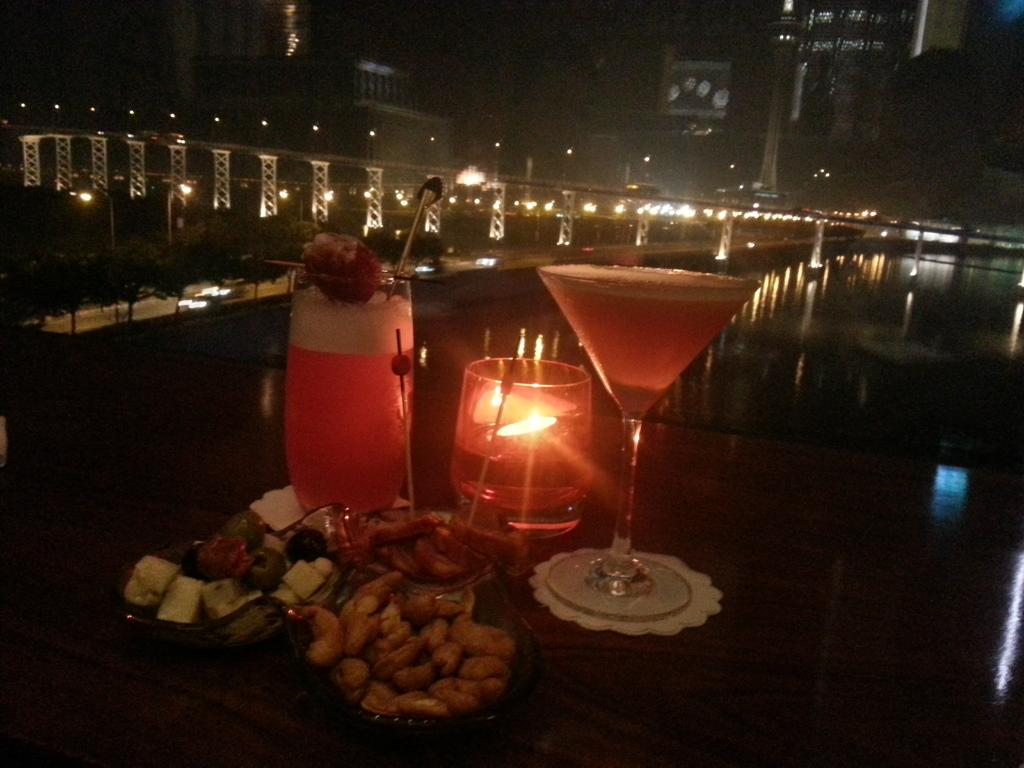What is located in the foreground of the image? There are sweets in the foreground of the image. What can be seen on a table in the image? There is a glass on a table in the image. What is inside the glass? The glass contains a liquid. How many apples are being ridden by the actor in the image? There is no actor or apples present in the image. What type of bike is visible in the image? There is no bike present in the image. 